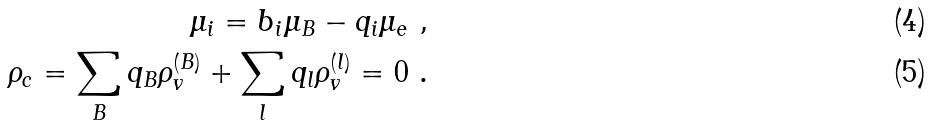<formula> <loc_0><loc_0><loc_500><loc_500>\mu _ { i } = b _ { i } \mu _ { B } - q _ { i } \mu _ { e } \ , \\ \rho _ { c } = \sum _ { B } q _ { B } \rho _ { v } ^ { ( B ) } + \sum _ { l } q _ { l } \rho _ { v } ^ { ( l ) } = 0 \ .</formula> 